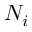<formula> <loc_0><loc_0><loc_500><loc_500>N _ { i }</formula> 